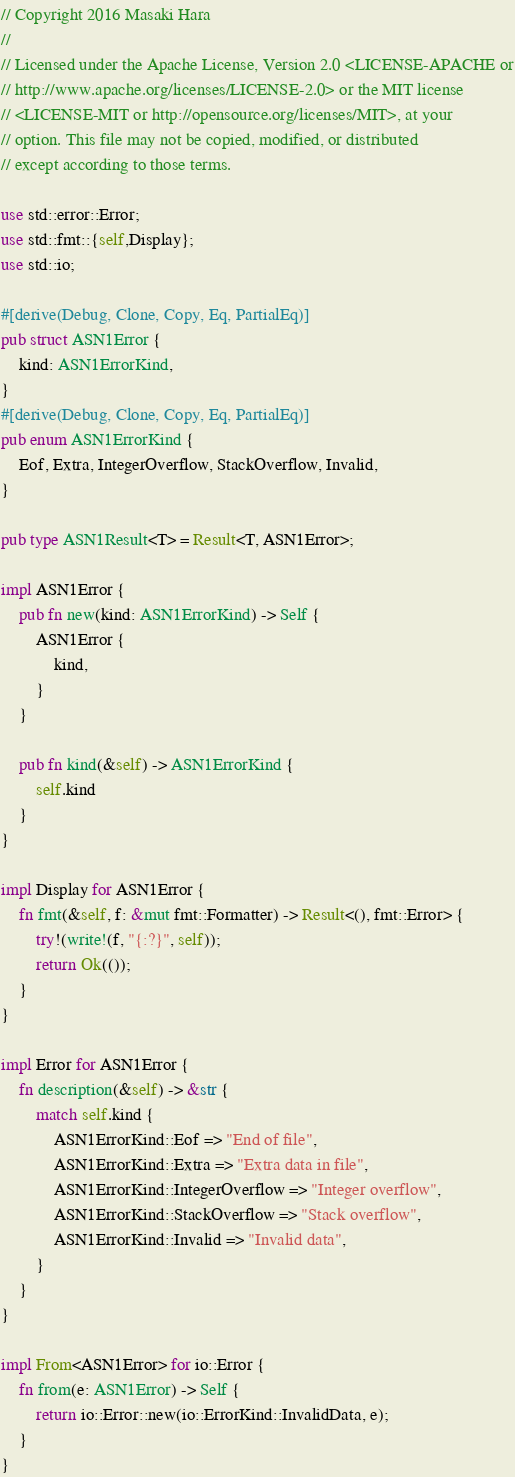Convert code to text. <code><loc_0><loc_0><loc_500><loc_500><_Rust_>// Copyright 2016 Masaki Hara
//
// Licensed under the Apache License, Version 2.0 <LICENSE-APACHE or
// http://www.apache.org/licenses/LICENSE-2.0> or the MIT license
// <LICENSE-MIT or http://opensource.org/licenses/MIT>, at your
// option. This file may not be copied, modified, or distributed
// except according to those terms.

use std::error::Error;
use std::fmt::{self,Display};
use std::io;

#[derive(Debug, Clone, Copy, Eq, PartialEq)]
pub struct ASN1Error {
    kind: ASN1ErrorKind,
}
#[derive(Debug, Clone, Copy, Eq, PartialEq)]
pub enum ASN1ErrorKind {
    Eof, Extra, IntegerOverflow, StackOverflow, Invalid,
}

pub type ASN1Result<T> = Result<T, ASN1Error>;

impl ASN1Error {
    pub fn new(kind: ASN1ErrorKind) -> Self {
        ASN1Error {
            kind,
        }
    }

    pub fn kind(&self) -> ASN1ErrorKind {
        self.kind
    }
}

impl Display for ASN1Error {
    fn fmt(&self, f: &mut fmt::Formatter) -> Result<(), fmt::Error> {
        try!(write!(f, "{:?}", self));
        return Ok(());
    }
}

impl Error for ASN1Error {
    fn description(&self) -> &str {
        match self.kind {
            ASN1ErrorKind::Eof => "End of file",
            ASN1ErrorKind::Extra => "Extra data in file",
            ASN1ErrorKind::IntegerOverflow => "Integer overflow",
            ASN1ErrorKind::StackOverflow => "Stack overflow",
            ASN1ErrorKind::Invalid => "Invalid data",
        }
    }
}

impl From<ASN1Error> for io::Error {
    fn from(e: ASN1Error) -> Self {
        return io::Error::new(io::ErrorKind::InvalidData, e);
    }
}
</code> 